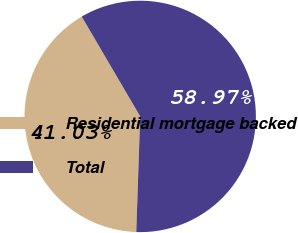<chart> <loc_0><loc_0><loc_500><loc_500><pie_chart><fcel>Residential mortgage backed<fcel>Total<nl><fcel>41.03%<fcel>58.97%<nl></chart> 